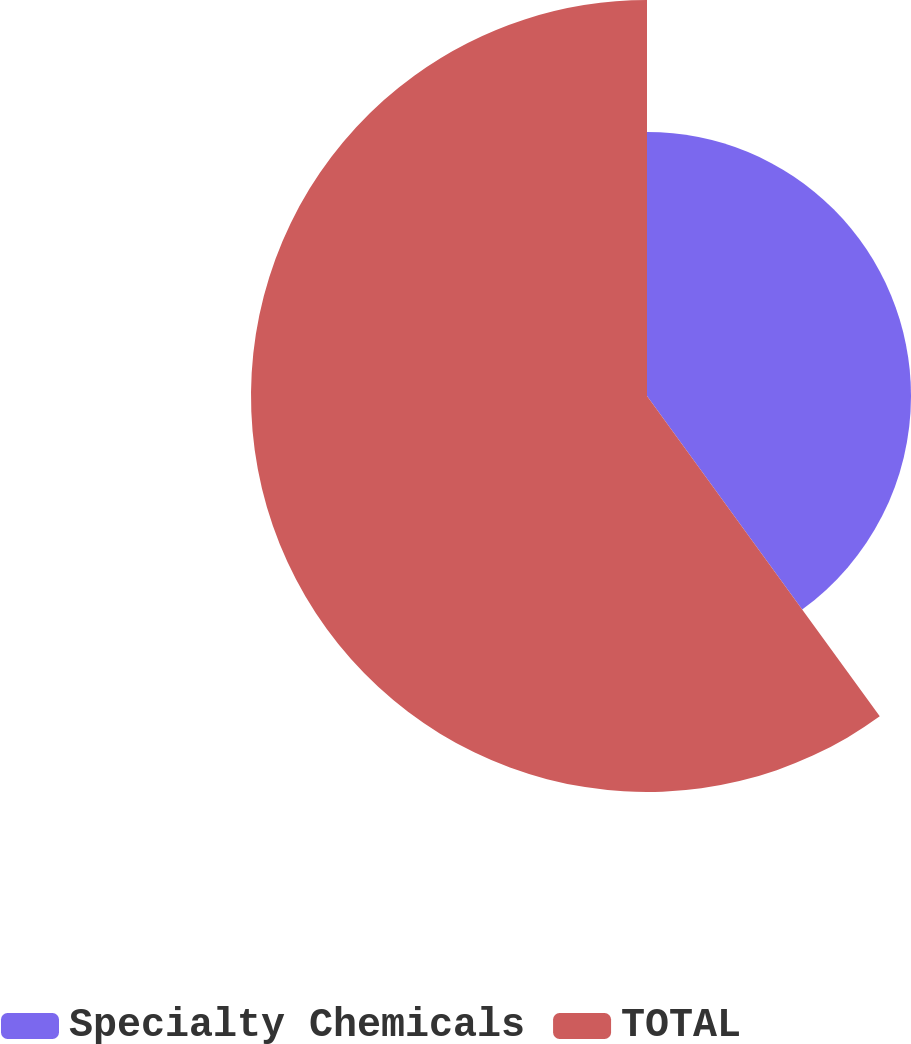<chart> <loc_0><loc_0><loc_500><loc_500><pie_chart><fcel>Specialty Chemicals<fcel>TOTAL<nl><fcel>40.0%<fcel>60.0%<nl></chart> 